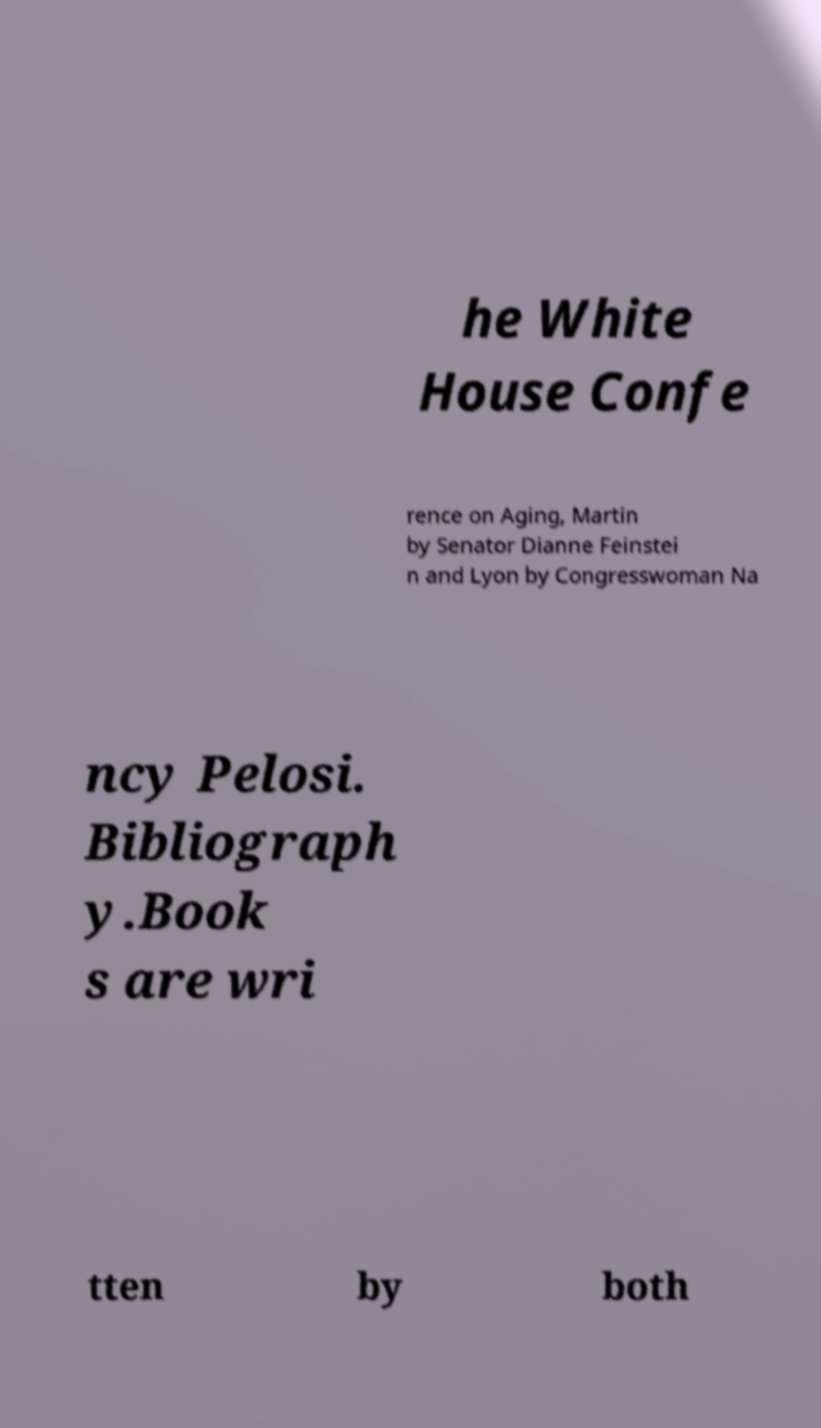Can you read and provide the text displayed in the image?This photo seems to have some interesting text. Can you extract and type it out for me? he White House Confe rence on Aging, Martin by Senator Dianne Feinstei n and Lyon by Congresswoman Na ncy Pelosi. Bibliograph y.Book s are wri tten by both 